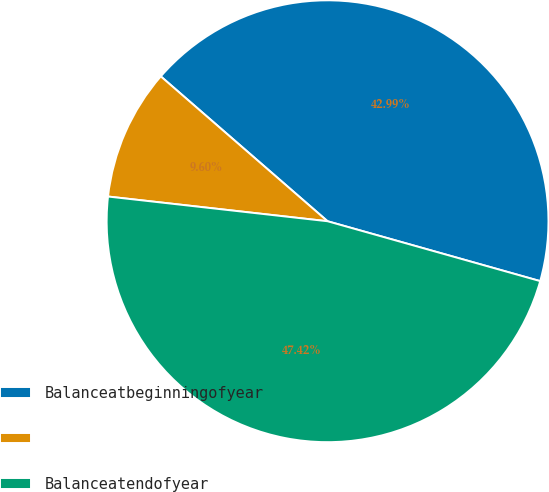<chart> <loc_0><loc_0><loc_500><loc_500><pie_chart><fcel>Balanceatbeginningofyear<fcel>Unnamed: 1<fcel>Balanceatendofyear<nl><fcel>42.99%<fcel>9.6%<fcel>47.42%<nl></chart> 